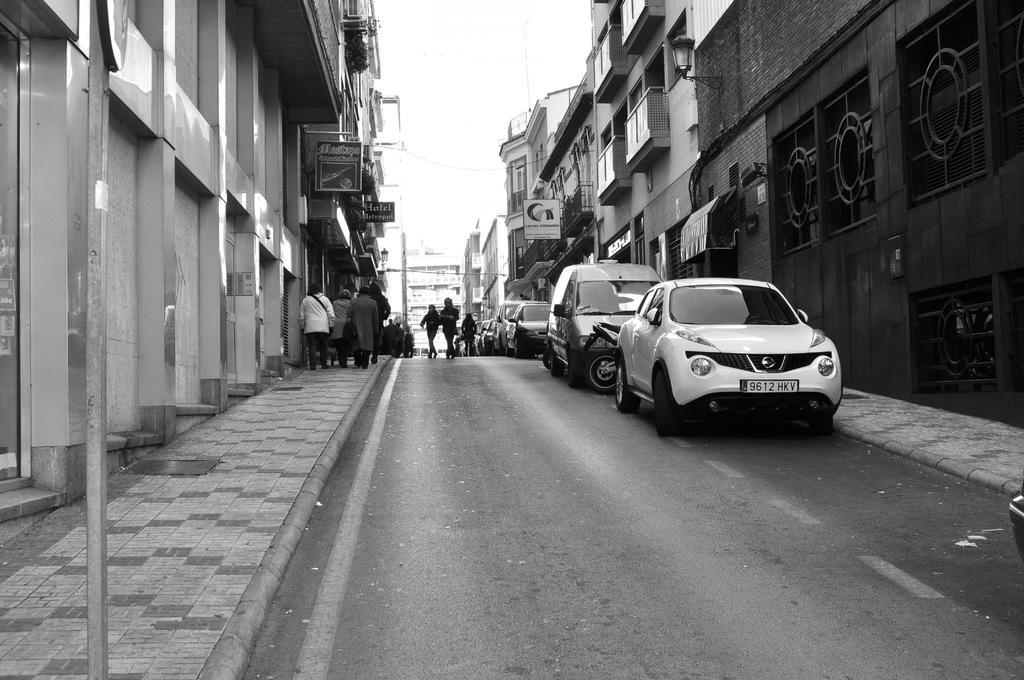How would you summarize this image in a sentence or two? This is a black and white image. There are groups of people walking. These are the cars and a motorbike, which are parked beside the road. I can see the buildings. This is a gate. These are the boards, which are attached to the building wall. I can see the pole. This is a lamp, which is attached to the wall. 